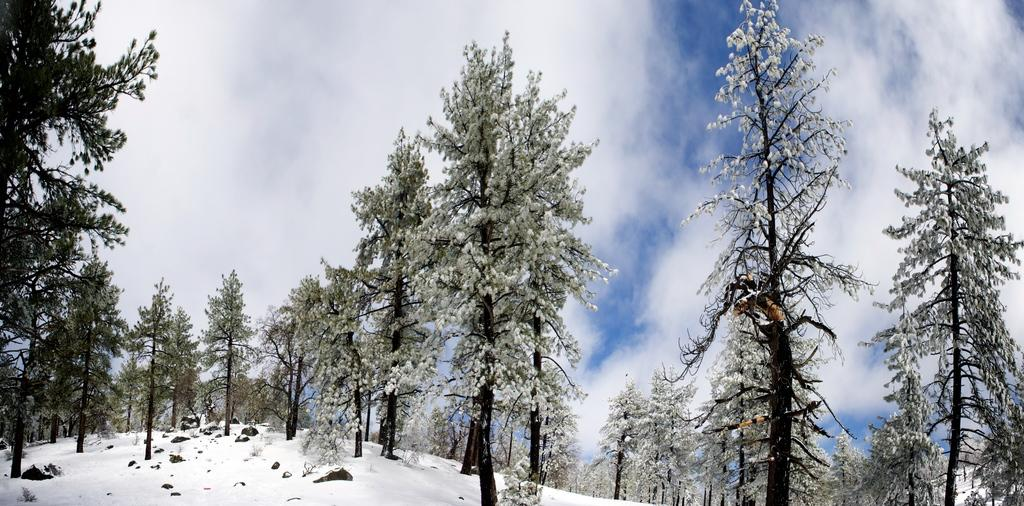What is present at the bottom of the image? There is snow and rocks at the bottom of the image. What can be seen in the background of the image? There are trees in the background of the image. What is visible in the sky in the background of the image? Clouds are present in the sky in the background of the image. What type of celery can be seen growing in the snow at the bottom of the image? There is no celery present in the image; it features snow and rocks at the bottom. How is the coil used in the image? There is no coil present in the image. 